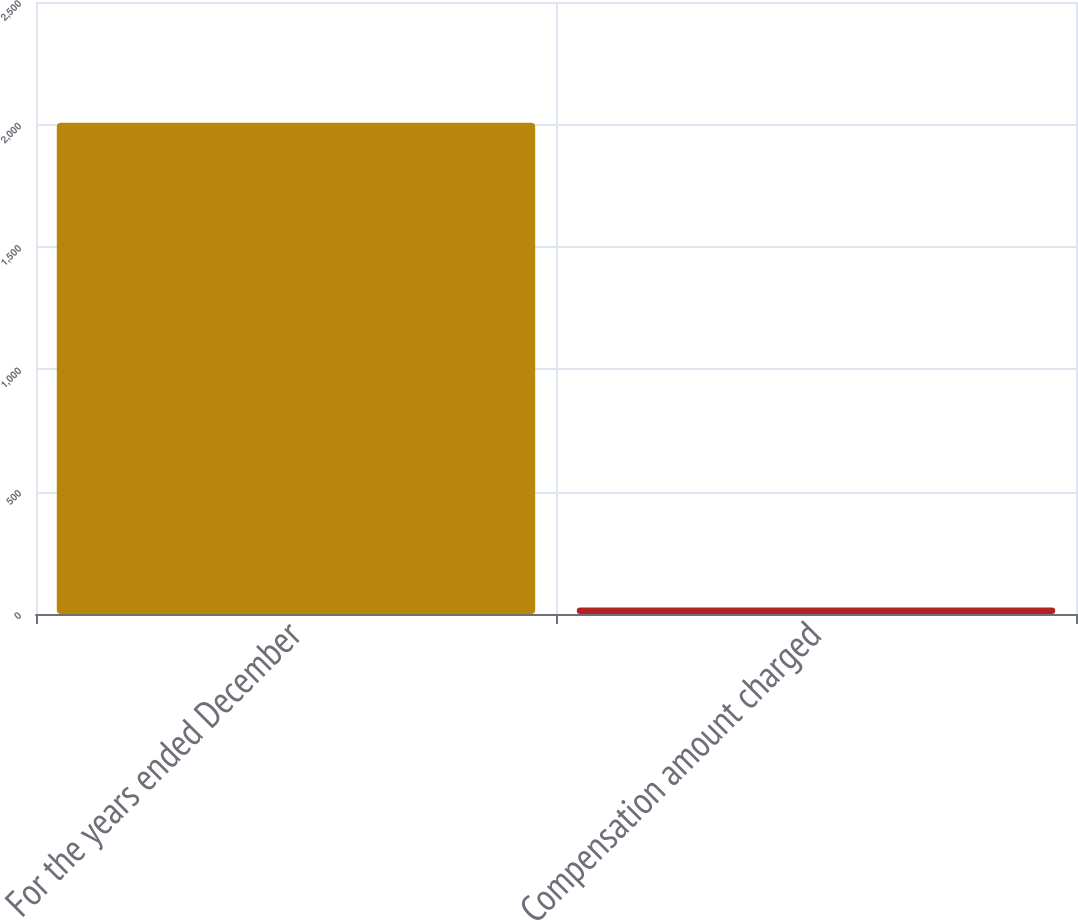Convert chart. <chart><loc_0><loc_0><loc_500><loc_500><bar_chart><fcel>For the years ended December<fcel>Compensation amount charged<nl><fcel>2007<fcel>26.8<nl></chart> 